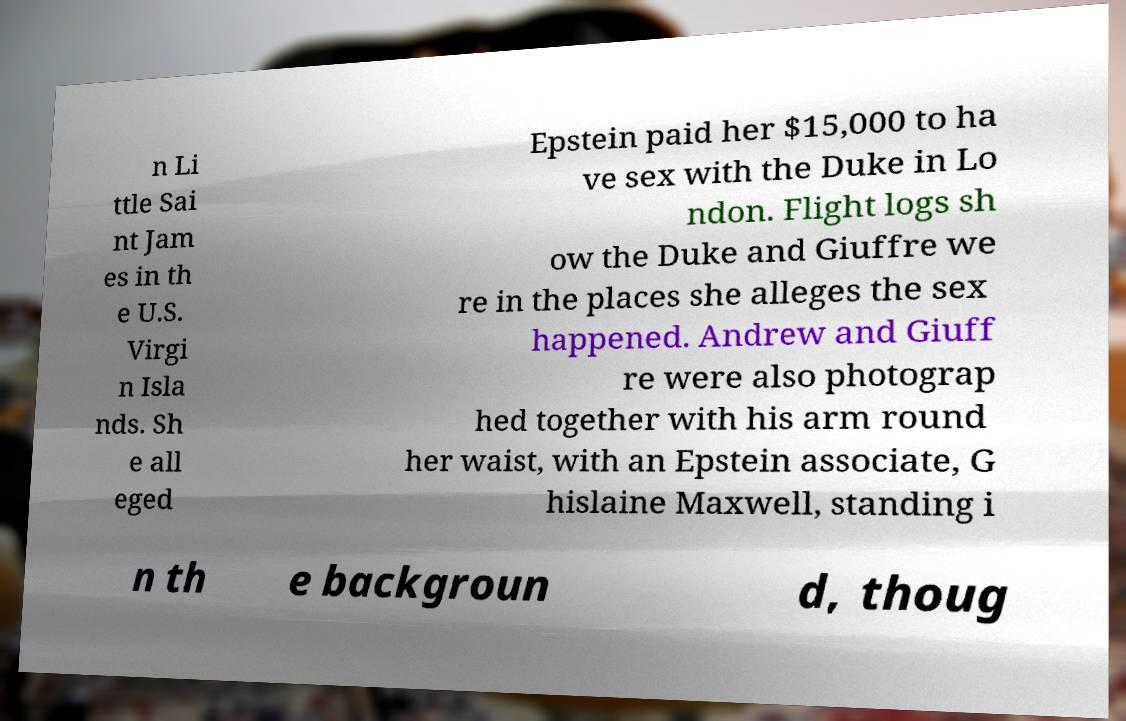Could you extract and type out the text from this image? n Li ttle Sai nt Jam es in th e U.S. Virgi n Isla nds. Sh e all eged Epstein paid her $15,000 to ha ve sex with the Duke in Lo ndon. Flight logs sh ow the Duke and Giuffre we re in the places she alleges the sex happened. Andrew and Giuff re were also photograp hed together with his arm round her waist, with an Epstein associate, G hislaine Maxwell, standing i n th e backgroun d, thoug 